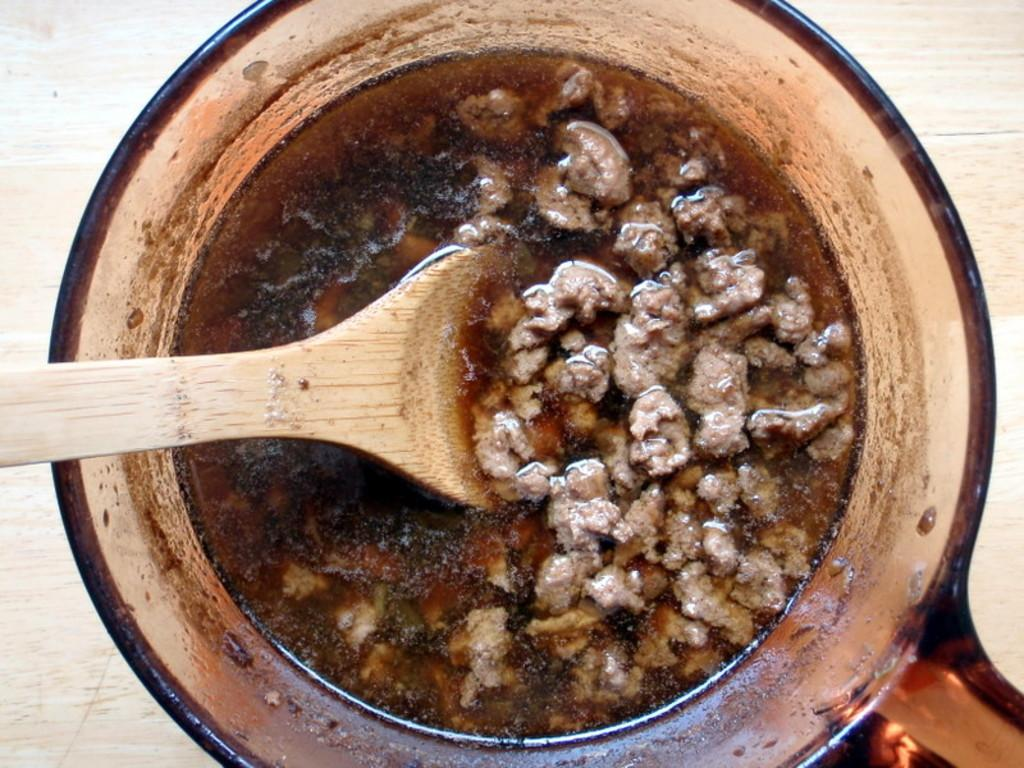What type of food can be seen in the image? There is food in the image, but the specific type is not mentioned. What else is present in the image besides food? There is liquid and a spatula in the image. Where are the food, liquid, and spatula located? They are all in a bowl. What is the bowl resting on in the image? The bowl is on a wooden surface. What type of mailbox is visible in the image? There is no mailbox present in the image. Can you describe the fork used to stir the food in the image? There is no fork mentioned or visible in the image; instead, a spatula is present. 